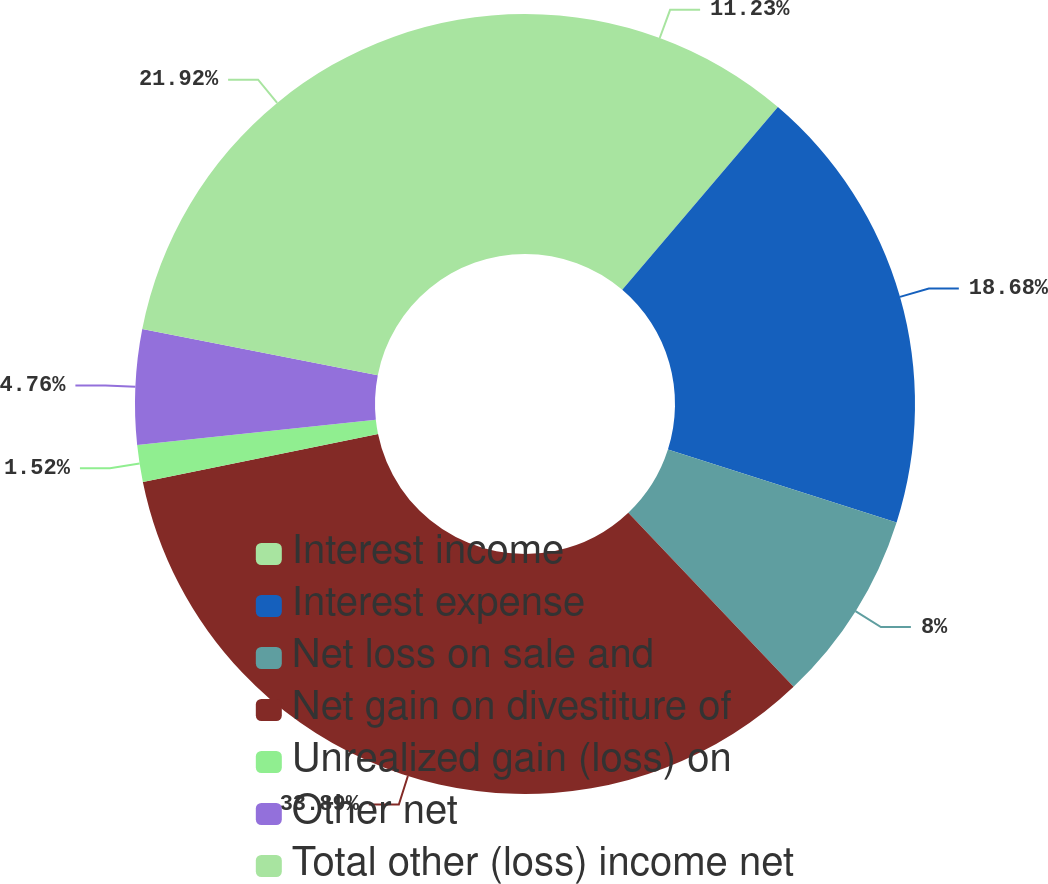<chart> <loc_0><loc_0><loc_500><loc_500><pie_chart><fcel>Interest income<fcel>Interest expense<fcel>Net loss on sale and<fcel>Net gain on divestiture of<fcel>Unrealized gain (loss) on<fcel>Other net<fcel>Total other (loss) income net<nl><fcel>11.23%<fcel>18.68%<fcel>8.0%<fcel>33.89%<fcel>1.52%<fcel>4.76%<fcel>21.92%<nl></chart> 